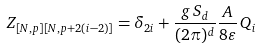Convert formula to latex. <formula><loc_0><loc_0><loc_500><loc_500>Z _ { [ N , p ] [ N , p + 2 ( i - 2 ) ] } = \delta _ { 2 i } + \frac { g \, S _ { d } } { ( 2 \pi ) ^ { d } } \frac { A } { 8 \varepsilon } \, Q _ { i }</formula> 